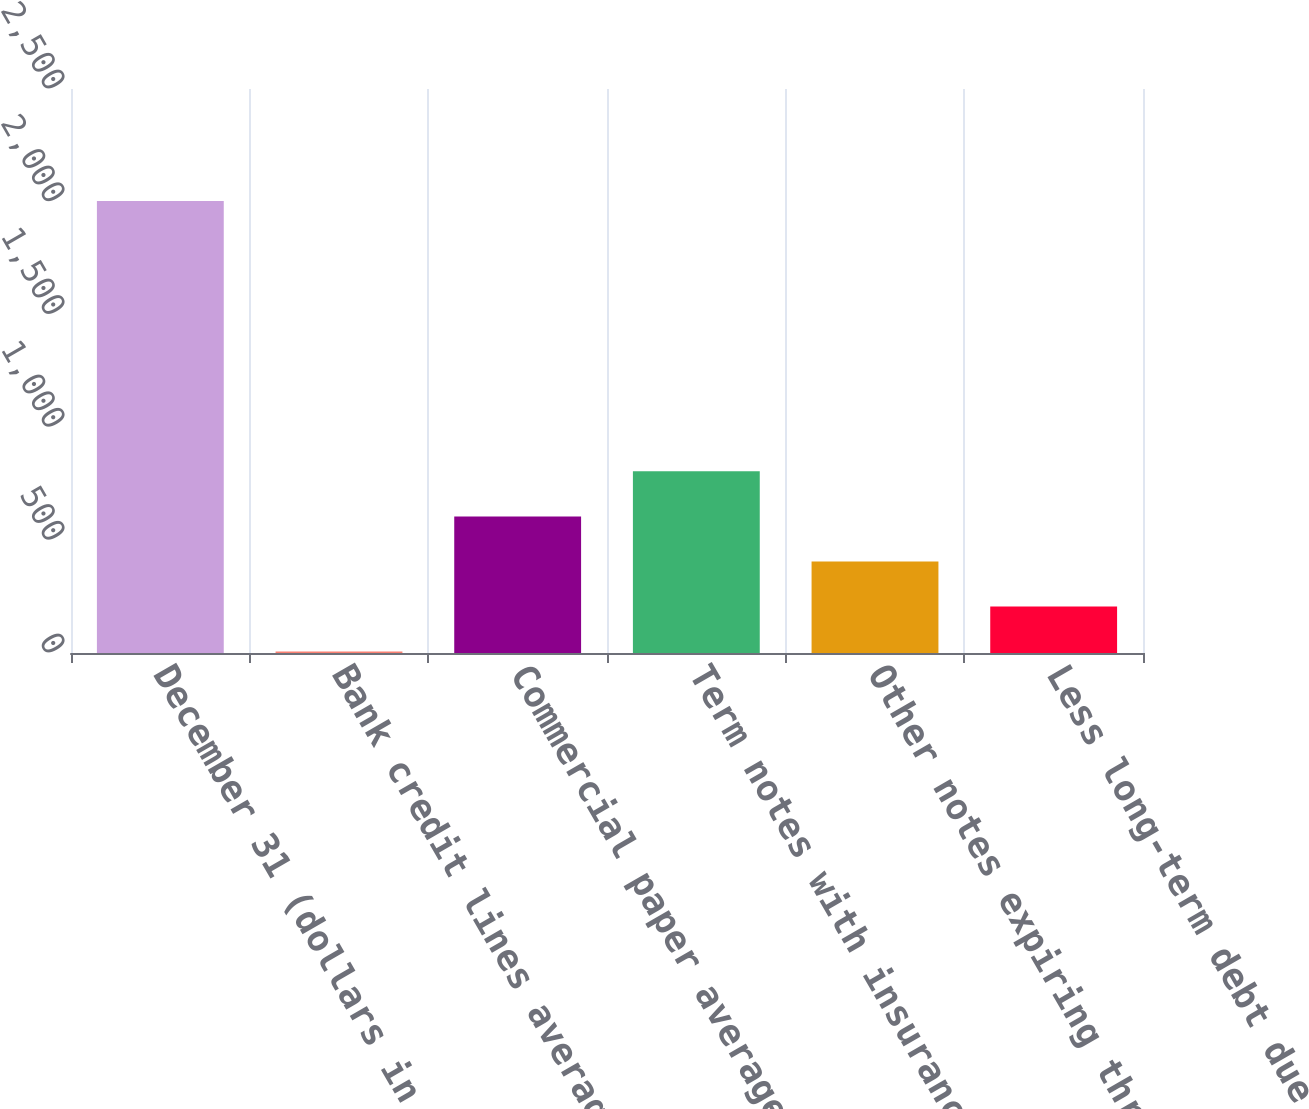Convert chart. <chart><loc_0><loc_0><loc_500><loc_500><bar_chart><fcel>December 31 (dollars in<fcel>Bank credit lines average<fcel>Commercial paper average<fcel>Term notes with insurance<fcel>Other notes expiring through<fcel>Less long-term debt due within<nl><fcel>2003<fcel>6.5<fcel>605.45<fcel>805.1<fcel>405.8<fcel>206.15<nl></chart> 